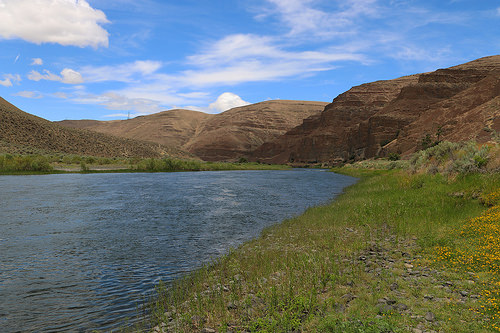<image>
Is there a sky behind the mountain? Yes. From this viewpoint, the sky is positioned behind the mountain, with the mountain partially or fully occluding the sky. 